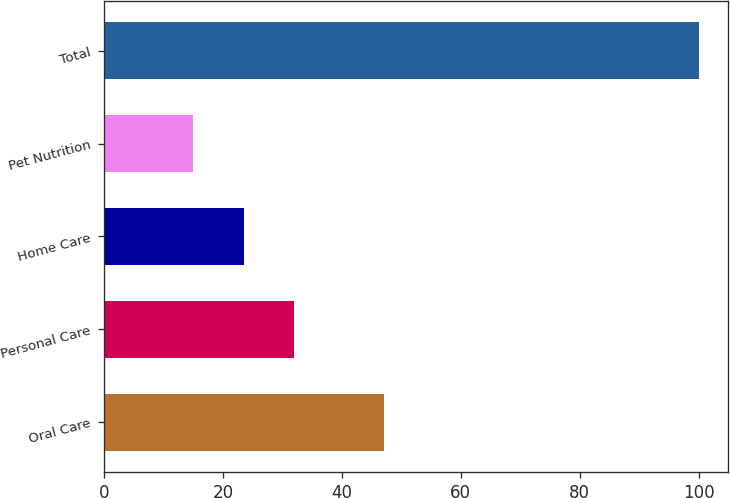Convert chart to OTSL. <chart><loc_0><loc_0><loc_500><loc_500><bar_chart><fcel>Oral Care<fcel>Personal Care<fcel>Home Care<fcel>Pet Nutrition<fcel>Total<nl><fcel>47<fcel>32<fcel>23.5<fcel>15<fcel>100<nl></chart> 